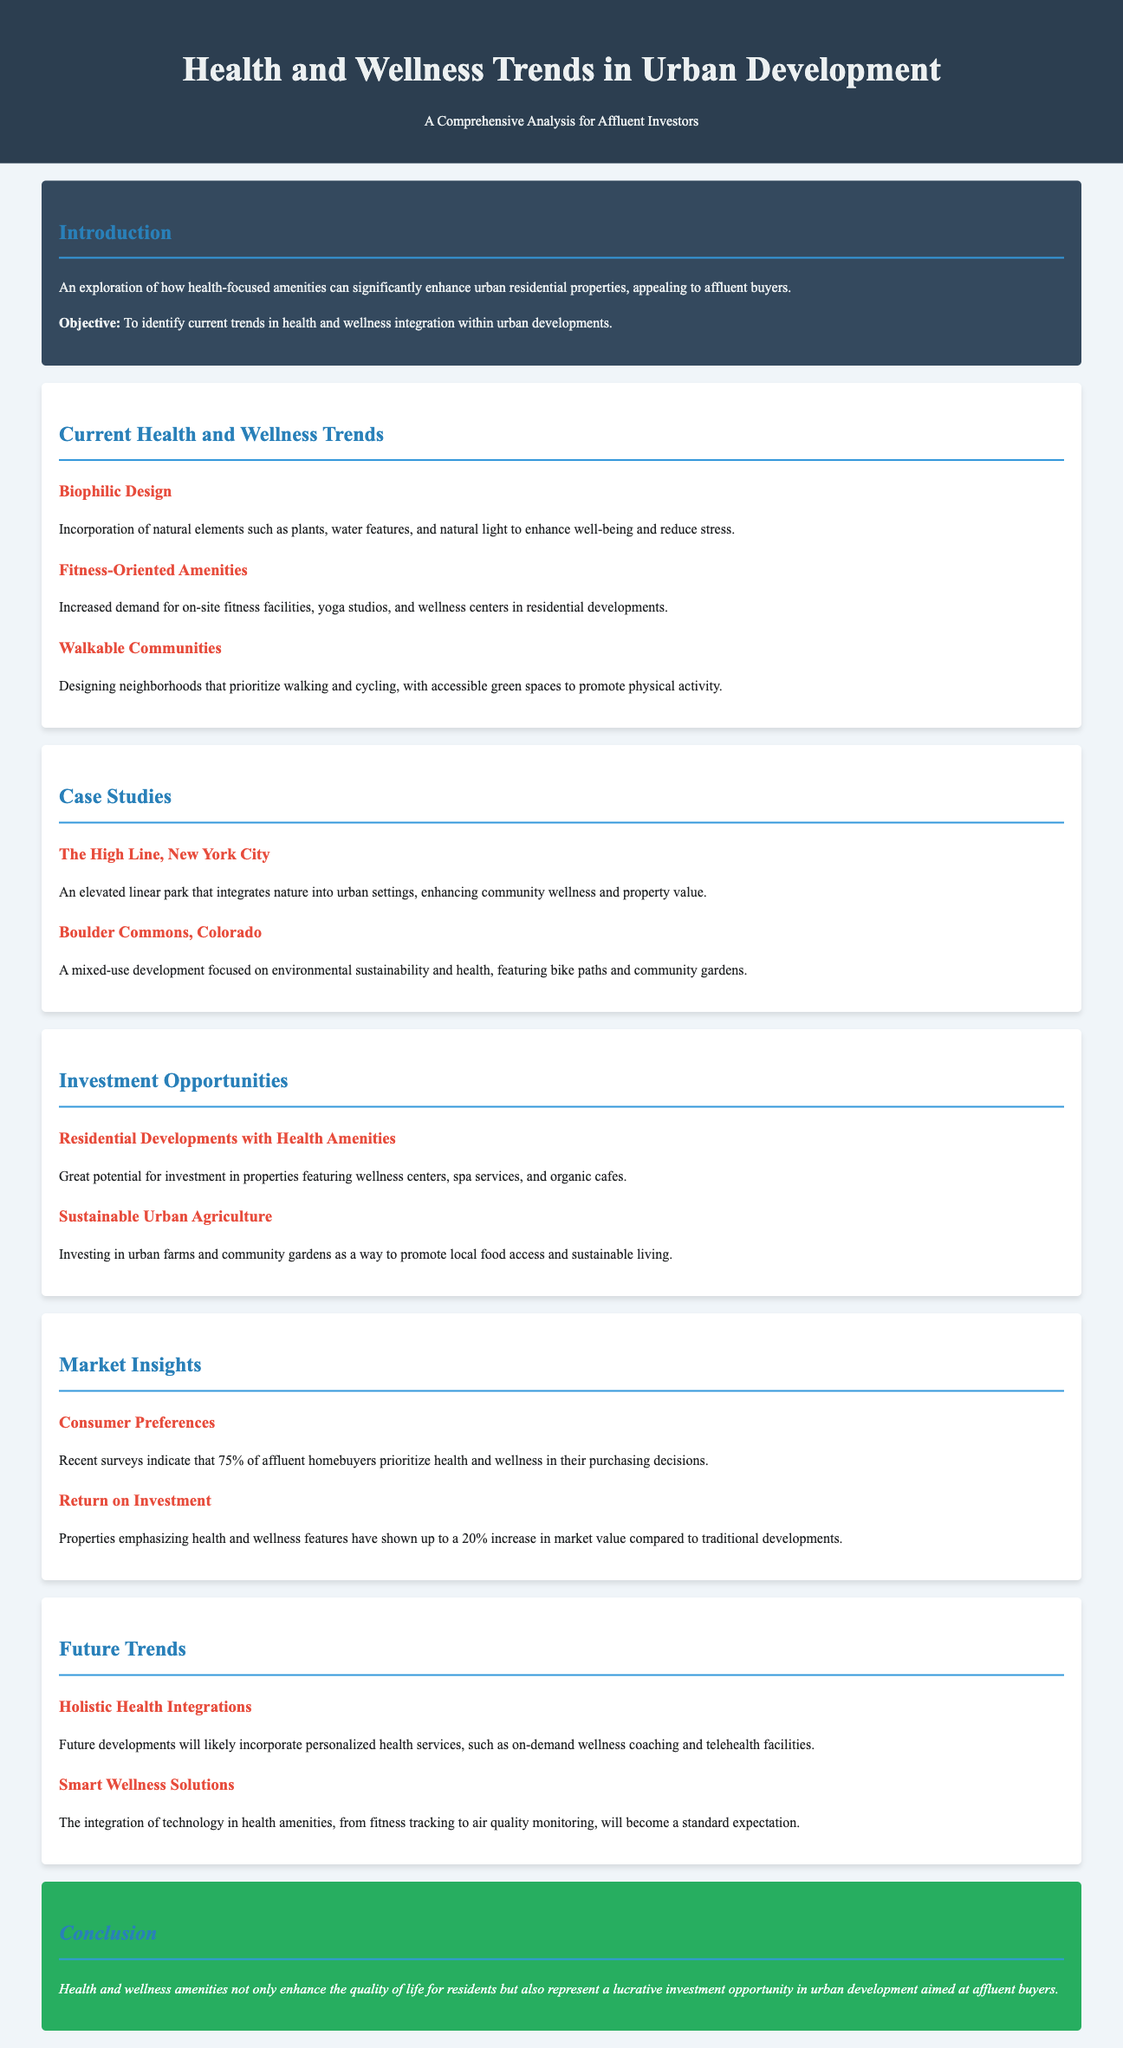What is the primary objective of the document? The objective of the document is to identify current trends in health and wellness integration within urban developments.
Answer: To identify current trends in health and wellness integration within urban developments What percentage of affluent homebuyers prioritize health and wellness? The document states that recent surveys indicate 75% of affluent homebuyers prioritize health and wellness in their purchasing decisions.
Answer: 75% What case study features a linear park in New York City? The document mentions "The High Line, New York City" as a case study that integrates nature into urban settings.
Answer: The High Line, New York City What type of design incorporates natural elements like plants and water features? The section discusses "Biophilic Design" as an incorporation of natural elements to enhance well-being and reduce stress.
Answer: Biophilic Design What investment opportunity is mentioned that focuses on sustainable living? The document highlights "Sustainable Urban Agriculture" as an investment in urban farms and community gardens.
Answer: Sustainable Urban Agriculture What holistic feature is expected in future urban developments? The document anticipates "personalized health services" such as wellness coaching and telehealth facilities in future developments.
Answer: Personalized health services How much increase in market value do properties emphasizing health features show? The document indicates that properties with health and wellness features have shown up to a 20% increase in market value compared to traditional developments.
Answer: 20% What are the two future trends discussed in the document? The document mentions "Holistic Health Integrations" and "Smart Wellness Solutions" as future trends in urban development.
Answer: Holistic Health Integrations and Smart Wellness Solutions 